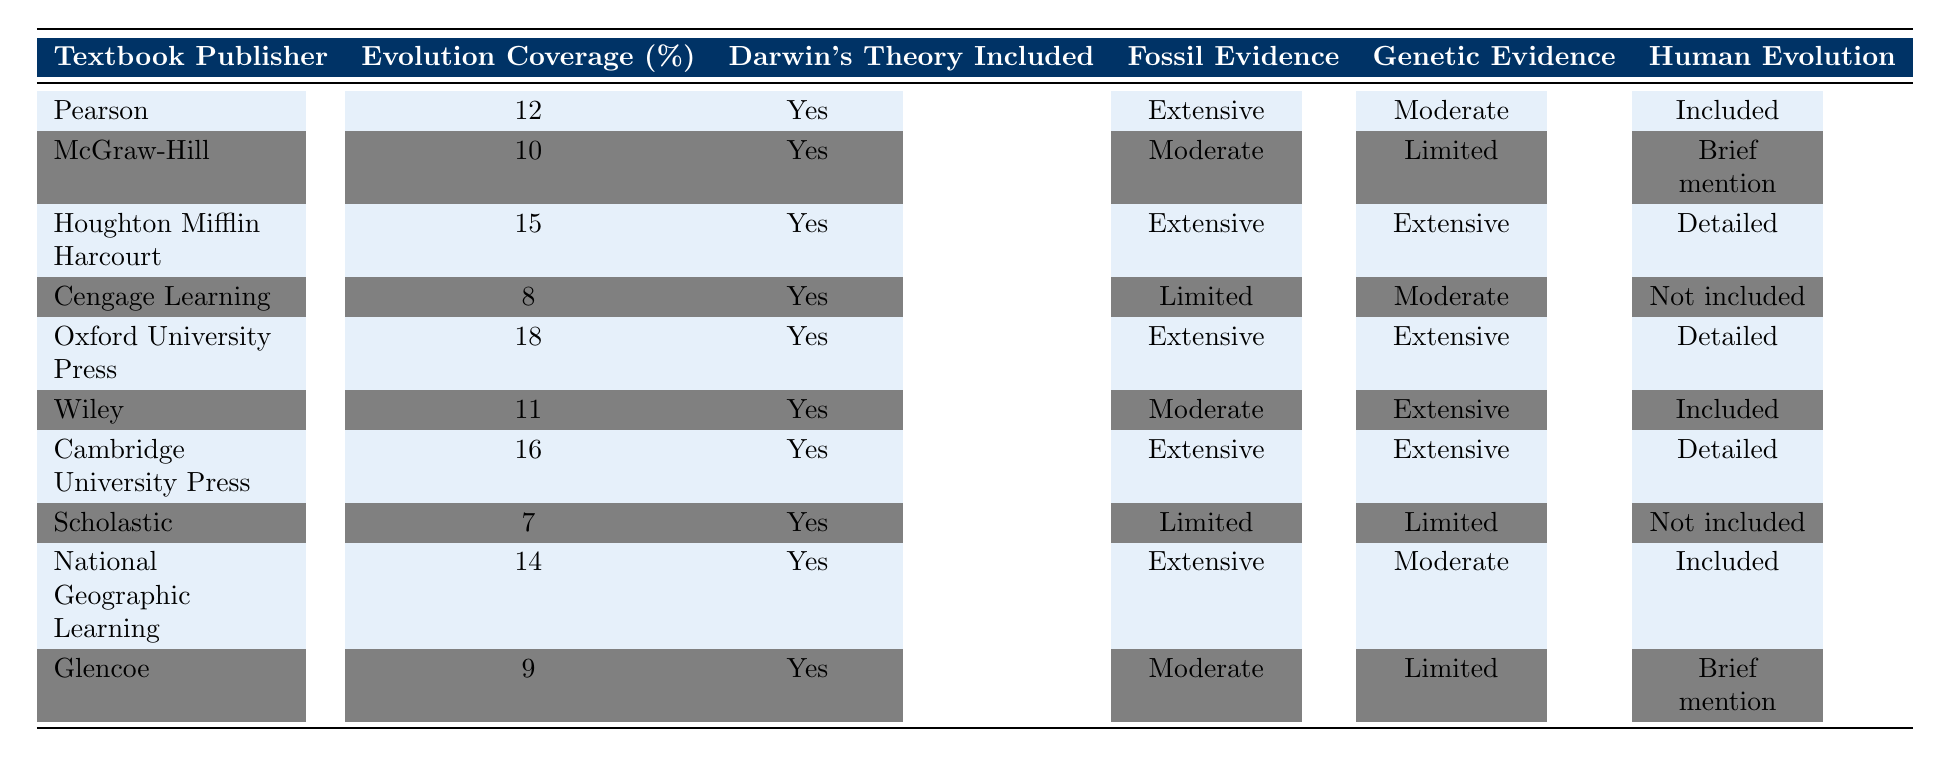What is the evolution coverage percentage for Oxford University Press? From the table, we can locate the row for Oxford University Press and directly read the value in the "Evolution Coverage (%)" column. It indicates a value of 18.
Answer: 18 Which publisher has the least coverage of evolution? By scanning through the "Evolution Coverage (%)" column, Cengage Learning has the lowest value at 8, making it the publisher with the least coverage.
Answer: Cengage Learning Did Scholastic include information about human evolution? Checking the row for Scholastic, the "Human Evolution" column shows "Not included," indicating that human evolution is not covered in its textbooks.
Answer: No How many publishers included extensive fossil evidence? To find this, we go through the "Fossil Evidence" column and count the number of publishers that list "Extensive." Upon counting, we find six publishers with that designation.
Answer: 6 What is the average evolution coverage percentage of all publishers listed? We take the values from the "Evolution Coverage (%)" column: 12, 10, 15, 8, 18, 11, 16, 7, 14, 9. Adding them gives a total of 130. Since there are 10 publishers, we divide 130 by 10, resulting in an average of 13.
Answer: 13 Which textbook publisher provided "detailed" information on human evolution? Examining the "Human Evolution" column closely, the publishers that show "Detailed" are Houghton Mifflin Harcourt, Oxford University Press, and Cambridge University Press.
Answer: Houghton Mifflin Harcourt, Oxford University Press, Cambridge University Press What is the difference between the highest and lowest evolution coverage percentages? The highest coverage is 18 (by Oxford University Press) and the lowest is 7 (by Scholastic). Subtracting these values (18 - 7) gives a difference of 11.
Answer: 11 Is there any publisher that did not include Darwin's theory in their textbook? Going through the "Darwin's Theory Included" column, we find that all publishers listed indicate "Yes" for including Darwin's theory, meaning there are no publishers that excluded it.
Answer: No Which publisher has both extensive fossil and genetic evidence coverage? We inspect both the "Fossil Evidence" and "Genetic Evidence." The publishers that have "Extensive" in both columns are Houghton Mifflin Harcourt, Oxford University Press, and Cambridge University Press.
Answer: Houghton Mifflin Harcourt, Oxford University Press, Cambridge University Press 